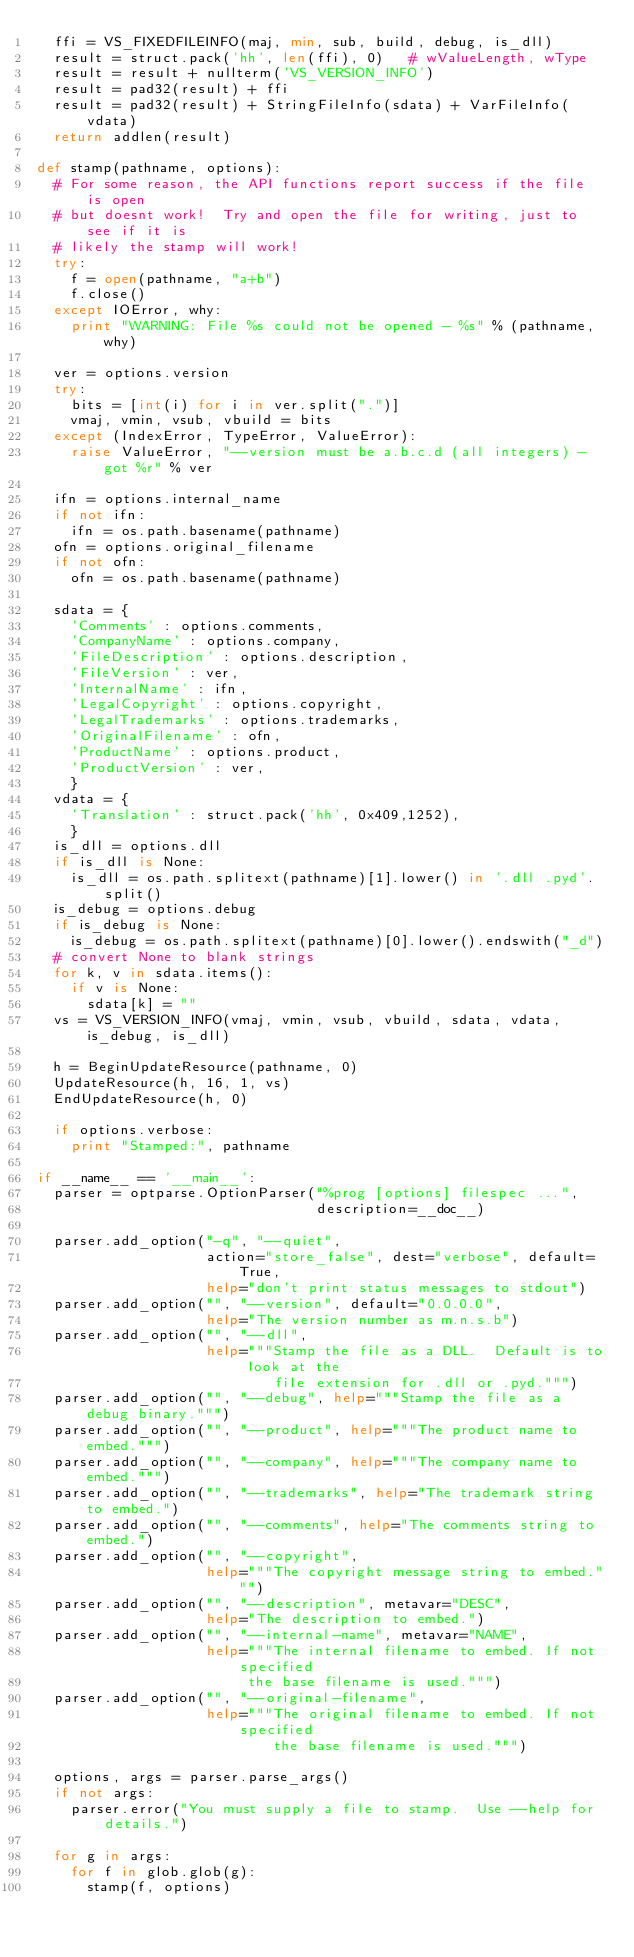Convert code to text. <code><loc_0><loc_0><loc_500><loc_500><_Python_>  ffi = VS_FIXEDFILEINFO(maj, min, sub, build, debug, is_dll)
  result = struct.pack('hh', len(ffi), 0)	# wValueLength, wType
  result = result + nullterm('VS_VERSION_INFO')
  result = pad32(result) + ffi
  result = pad32(result) + StringFileInfo(sdata) + VarFileInfo(vdata)
  return addlen(result)

def stamp(pathname, options):
  # For some reason, the API functions report success if the file is open
  # but doesnt work!  Try and open the file for writing, just to see if it is
  # likely the stamp will work!
  try:
    f = open(pathname, "a+b")
    f.close()
  except IOError, why:
    print "WARNING: File %s could not be opened - %s" % (pathname, why)

  ver = options.version
  try:
    bits = [int(i) for i in ver.split(".")]
    vmaj, vmin, vsub, vbuild = bits
  except (IndexError, TypeError, ValueError):
    raise ValueError, "--version must be a.b.c.d (all integers) - got %r" % ver
  
  ifn = options.internal_name
  if not ifn:
    ifn = os.path.basename(pathname)
  ofn = options.original_filename
  if not ofn:
    ofn = os.path.basename(pathname)

  sdata = {
    'Comments' : options.comments,
    'CompanyName' : options.company,
    'FileDescription' : options.description,
    'FileVersion' : ver,
    'InternalName' : ifn,
    'LegalCopyright' : options.copyright,
    'LegalTrademarks' : options.trademarks,
    'OriginalFilename' : ofn,
    'ProductName' : options.product,
    'ProductVersion' : ver,
    }
  vdata = {
    'Translation' : struct.pack('hh', 0x409,1252),
    }
  is_dll = options.dll
  if is_dll is None:
    is_dll = os.path.splitext(pathname)[1].lower() in '.dll .pyd'.split()
  is_debug = options.debug
  if is_debug is None:
    is_debug = os.path.splitext(pathname)[0].lower().endswith("_d")
  # convert None to blank strings
  for k, v in sdata.items():
    if v is None:
      sdata[k] = ""
  vs = VS_VERSION_INFO(vmaj, vmin, vsub, vbuild, sdata, vdata, is_debug, is_dll)

  h = BeginUpdateResource(pathname, 0)
  UpdateResource(h, 16, 1, vs)
  EndUpdateResource(h, 0)

  if options.verbose:
    print "Stamped:", pathname

if __name__ == '__main__':
  parser = optparse.OptionParser("%prog [options] filespec ...",
                                 description=__doc__)

  parser.add_option("-q", "--quiet",
                    action="store_false", dest="verbose", default=True,
                    help="don't print status messages to stdout")
  parser.add_option("", "--version", default="0.0.0.0",
                    help="The version number as m.n.s.b")
  parser.add_option("", "--dll",
                    help="""Stamp the file as a DLL.  Default is to look at the
                            file extension for .dll or .pyd.""")
  parser.add_option("", "--debug", help="""Stamp the file as a debug binary.""")
  parser.add_option("", "--product", help="""The product name to embed.""")
  parser.add_option("", "--company", help="""The company name to embed.""")
  parser.add_option("", "--trademarks", help="The trademark string to embed.")
  parser.add_option("", "--comments", help="The comments string to embed.")
  parser.add_option("", "--copyright",
                    help="""The copyright message string to embed.""")
  parser.add_option("", "--description", metavar="DESC",
                    help="The description to embed.")
  parser.add_option("", "--internal-name", metavar="NAME",
                    help="""The internal filename to embed. If not specified
                         the base filename is used.""")
  parser.add_option("", "--original-filename",
                    help="""The original filename to embed. If not specified
                            the base filename is used.""")
  
  options, args = parser.parse_args()
  if not args:
    parser.error("You must supply a file to stamp.  Use --help for details.")
  
  for g in args:
    for f in glob.glob(g):
      stamp(f, options)
</code> 